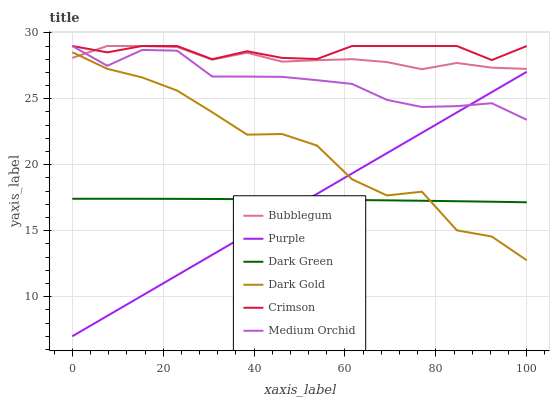Does Purple have the minimum area under the curve?
Answer yes or no. Yes. Does Crimson have the maximum area under the curve?
Answer yes or no. Yes. Does Medium Orchid have the minimum area under the curve?
Answer yes or no. No. Does Medium Orchid have the maximum area under the curve?
Answer yes or no. No. Is Purple the smoothest?
Answer yes or no. Yes. Is Dark Gold the roughest?
Answer yes or no. Yes. Is Medium Orchid the smoothest?
Answer yes or no. No. Is Medium Orchid the roughest?
Answer yes or no. No. Does Purple have the lowest value?
Answer yes or no. Yes. Does Medium Orchid have the lowest value?
Answer yes or no. No. Does Crimson have the highest value?
Answer yes or no. Yes. Does Purple have the highest value?
Answer yes or no. No. Is Purple less than Crimson?
Answer yes or no. Yes. Is Crimson greater than Dark Gold?
Answer yes or no. Yes. Does Dark Green intersect Purple?
Answer yes or no. Yes. Is Dark Green less than Purple?
Answer yes or no. No. Is Dark Green greater than Purple?
Answer yes or no. No. Does Purple intersect Crimson?
Answer yes or no. No. 